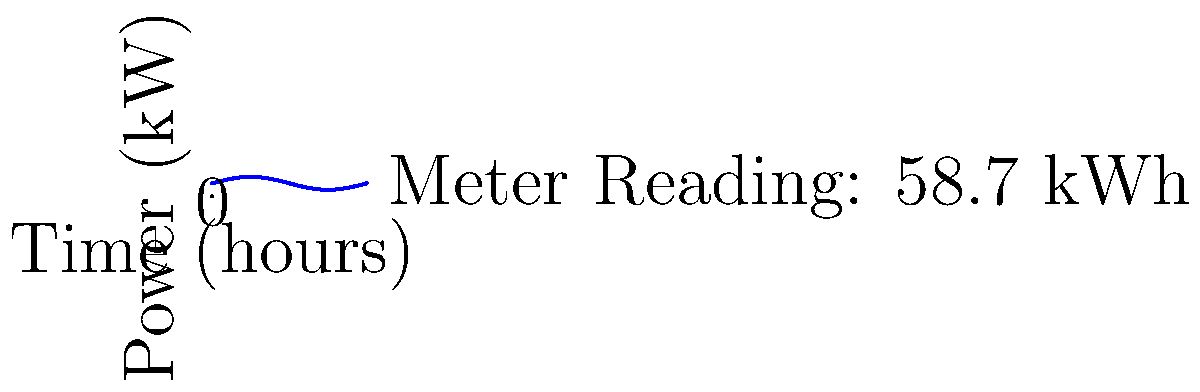As you reflect on your small-town upbringing and your friendship with Franklin, you're reminded of the importance of energy conservation. Looking at your electrical meter, you notice the reading is 58.7 kWh for a 24-hour period. The power consumption graph for this period is shown above. What was the average power consumption in kilowatts (kW) during this time? To solve this problem, we'll follow these steps:

1) First, recall that energy (in kWh) is the integral of power (in kW) over time (in hours).

2) We're given the total energy consumption for 24 hours: 58.7 kWh.

3) To find the average power, we need to divide the total energy by the time period:

   $$ \text{Average Power} = \frac{\text{Total Energy}}{\text{Time Period}} $$

4) Substituting our values:

   $$ \text{Average Power} = \frac{58.7 \text{ kWh}}{24 \text{ h}} $$

5) Perform the division:

   $$ \text{Average Power} = 2.4458333... \text{ kW} $$

6) Rounding to two decimal places for practicality:

   $$ \text{Average Power} \approx 2.45 \text{ kW} $$

This result aligns with the graph, which shows the power fluctuating around 2-3 kW over the 24-hour period.
Answer: 2.45 kW 